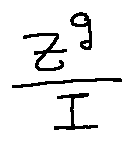<formula> <loc_0><loc_0><loc_500><loc_500>\frac { z ^ { g } } { I }</formula> 